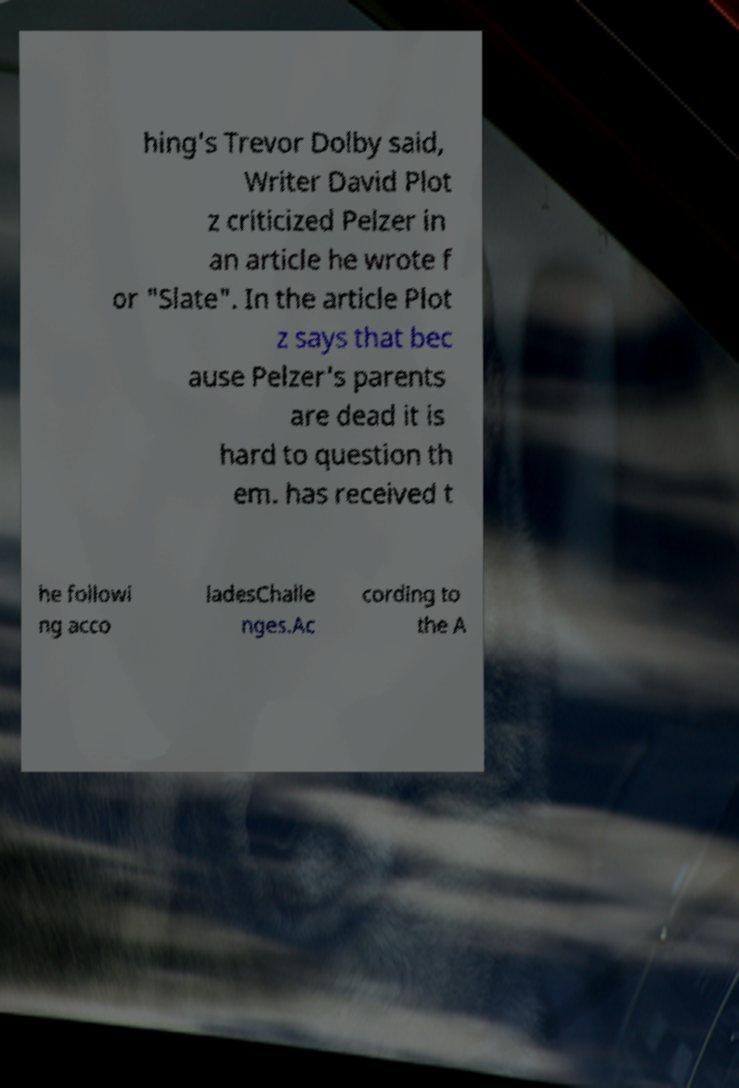I need the written content from this picture converted into text. Can you do that? hing's Trevor Dolby said, Writer David Plot z criticized Pelzer in an article he wrote f or "Slate". In the article Plot z says that bec ause Pelzer's parents are dead it is hard to question th em. has received t he followi ng acco ladesChalle nges.Ac cording to the A 